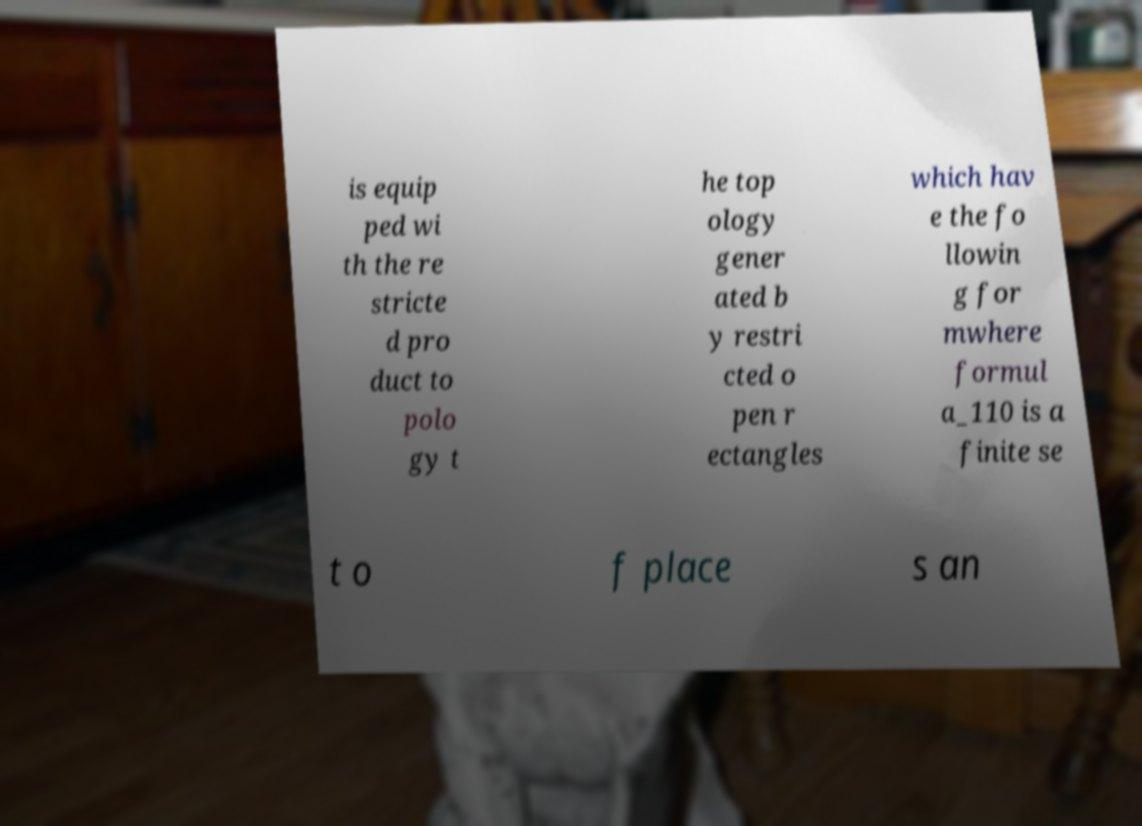Can you read and provide the text displayed in the image?This photo seems to have some interesting text. Can you extract and type it out for me? is equip ped wi th the re stricte d pro duct to polo gy t he top ology gener ated b y restri cted o pen r ectangles which hav e the fo llowin g for mwhere formul a_110 is a finite se t o f place s an 